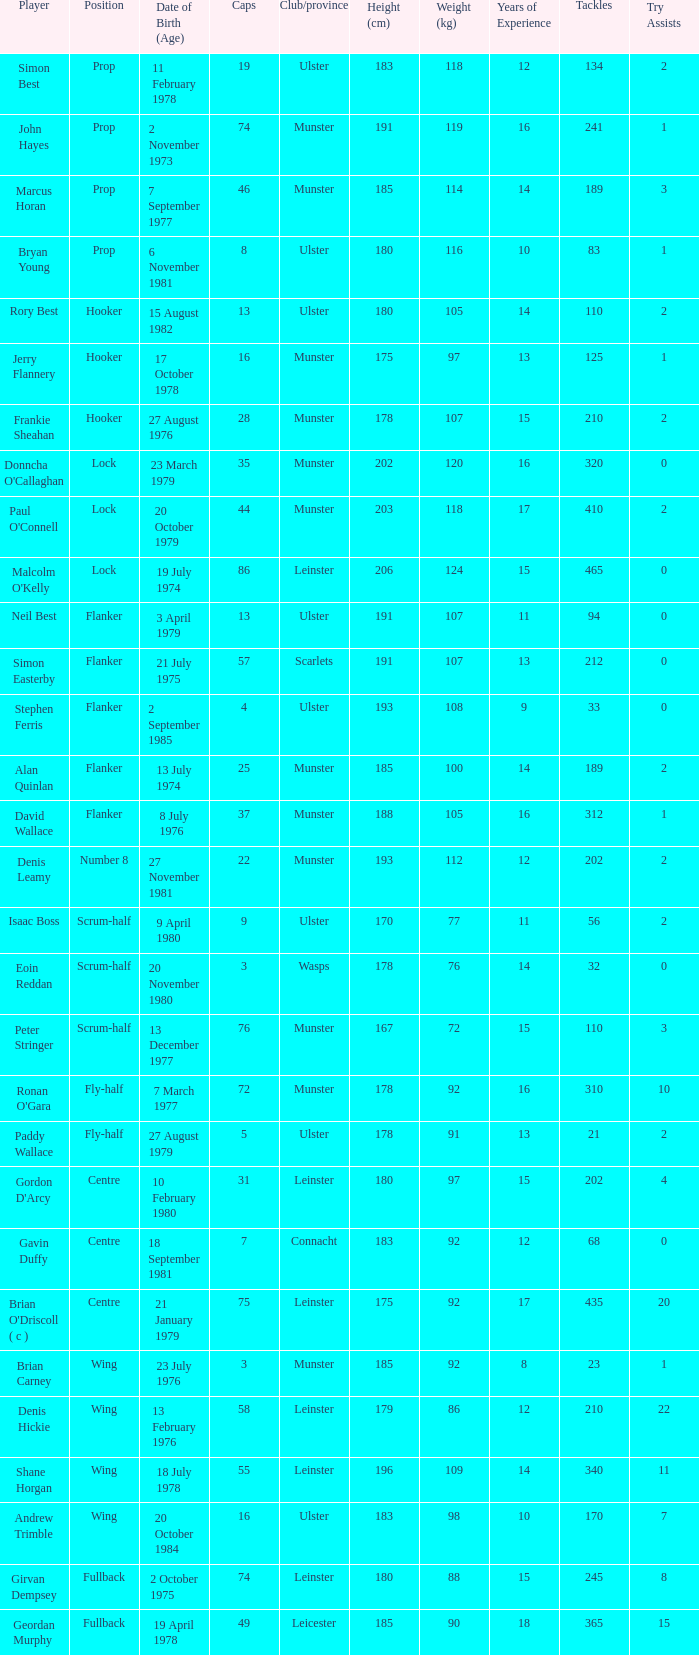Which player Munster from Munster is a fly-half? Ronan O'Gara. 